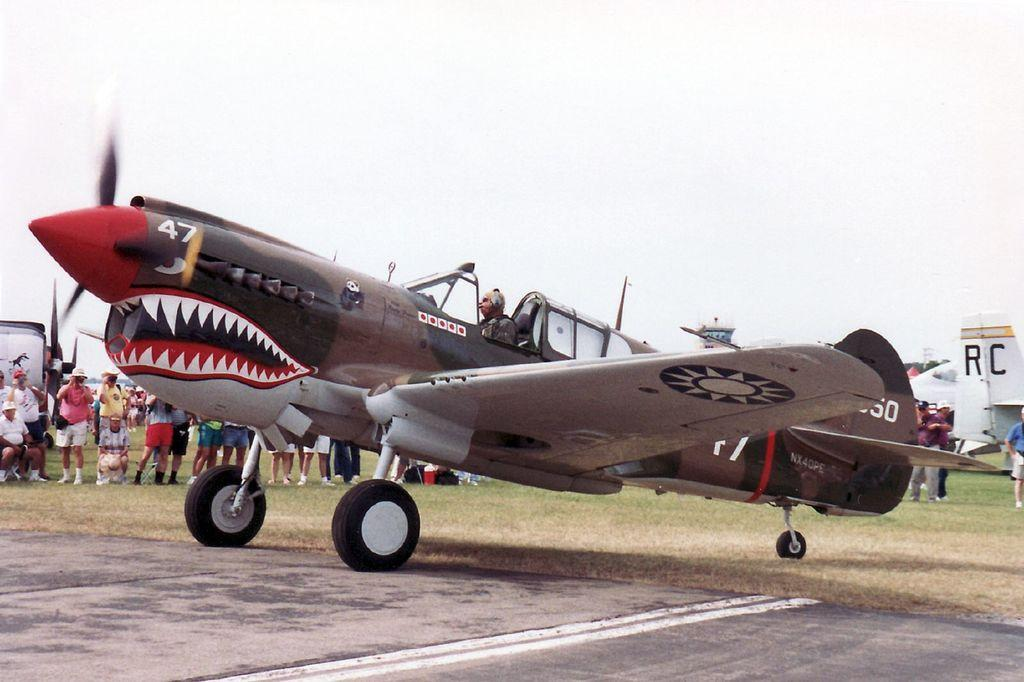<image>
Provide a brief description of the given image. a shark themed plane that sayd 47 on the side of the nose 